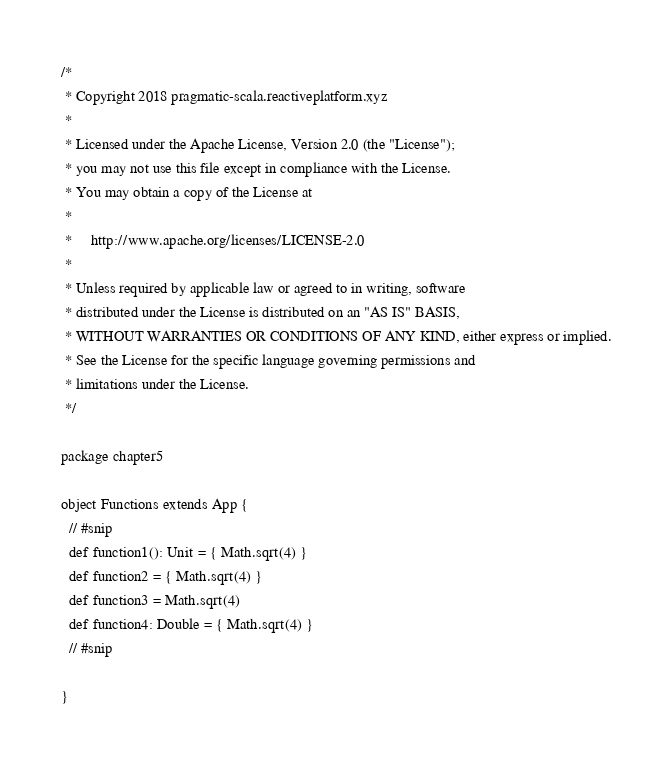Convert code to text. <code><loc_0><loc_0><loc_500><loc_500><_Scala_>/*
 * Copyright 2018 pragmatic-scala.reactiveplatform.xyz
 *
 * Licensed under the Apache License, Version 2.0 (the "License");
 * you may not use this file except in compliance with the License.
 * You may obtain a copy of the License at
 *
 *     http://www.apache.org/licenses/LICENSE-2.0
 *
 * Unless required by applicable law or agreed to in writing, software
 * distributed under the License is distributed on an "AS IS" BASIS,
 * WITHOUT WARRANTIES OR CONDITIONS OF ANY KIND, either express or implied.
 * See the License for the specific language governing permissions and
 * limitations under the License.
 */

package chapter5

object Functions extends App {
  // #snip
  def function1(): Unit = { Math.sqrt(4) }
  def function2 = { Math.sqrt(4) }
  def function3 = Math.sqrt(4)
  def function4: Double = { Math.sqrt(4) }
  // #snip

}
</code> 